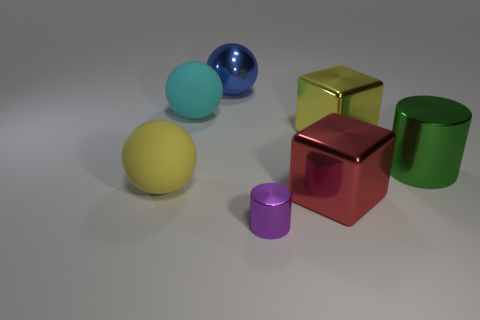There is a red thing that is the same size as the green object; what material is it?
Your answer should be compact. Metal. There is a yellow object to the left of the metallic object behind the yellow object that is behind the big shiny cylinder; what is its size?
Your answer should be compact. Large. Is the color of the cylinder that is behind the tiny purple object the same as the large ball that is in front of the large cyan ball?
Offer a very short reply. No. What number of cyan objects are either rubber things or big things?
Provide a succinct answer. 1. How many metallic blocks have the same size as the metal sphere?
Your answer should be very brief. 2. Is the material of the yellow thing that is on the left side of the big blue sphere the same as the small purple object?
Ensure brevity in your answer.  No. Are there any yellow things to the right of the big yellow object in front of the yellow metal thing?
Provide a succinct answer. Yes. There is another thing that is the same shape as the tiny purple metal object; what is it made of?
Offer a terse response. Metal. Are there more large cyan rubber objects that are behind the large blue metal ball than small purple cylinders behind the big red block?
Your response must be concise. No. There is a green thing that is the same material as the blue sphere; what is its shape?
Give a very brief answer. Cylinder. 